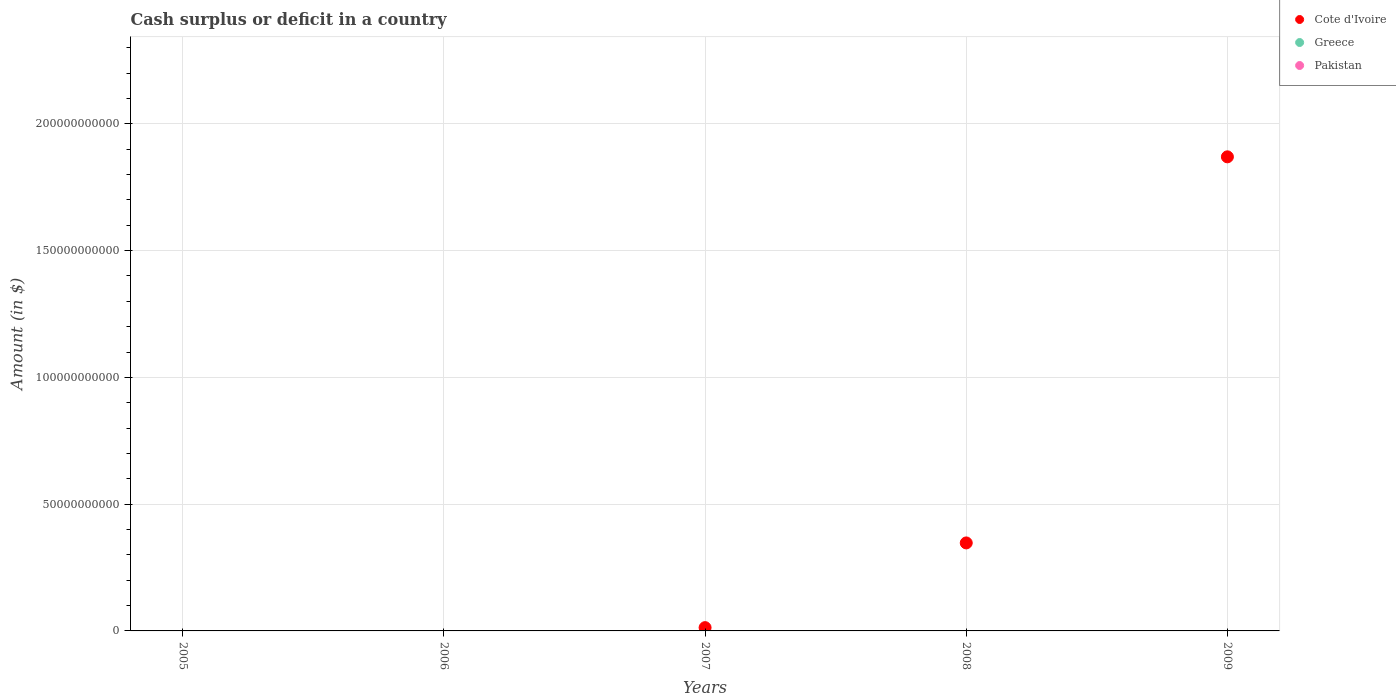How many different coloured dotlines are there?
Keep it short and to the point. 1. What is the amount of cash surplus or deficit in Pakistan in 2007?
Give a very brief answer. 0. Across all years, what is the maximum amount of cash surplus or deficit in Cote d'Ivoire?
Provide a short and direct response. 1.87e+11. In which year was the amount of cash surplus or deficit in Cote d'Ivoire maximum?
Offer a terse response. 2009. What is the total amount of cash surplus or deficit in Cote d'Ivoire in the graph?
Offer a terse response. 2.23e+11. What is the difference between the amount of cash surplus or deficit in Cote d'Ivoire in 2007 and that in 2008?
Your answer should be compact. -3.34e+1. What is the difference between the amount of cash surplus or deficit in Cote d'Ivoire in 2006 and the amount of cash surplus or deficit in Pakistan in 2008?
Provide a short and direct response. 0. What is the ratio of the amount of cash surplus or deficit in Cote d'Ivoire in 2007 to that in 2008?
Offer a very short reply. 0.04. What is the difference between the highest and the second highest amount of cash surplus or deficit in Cote d'Ivoire?
Your answer should be very brief. 1.52e+11. What is the difference between the highest and the lowest amount of cash surplus or deficit in Cote d'Ivoire?
Provide a short and direct response. 1.87e+11. In how many years, is the amount of cash surplus or deficit in Cote d'Ivoire greater than the average amount of cash surplus or deficit in Cote d'Ivoire taken over all years?
Your response must be concise. 1. Is it the case that in every year, the sum of the amount of cash surplus or deficit in Pakistan and amount of cash surplus or deficit in Greece  is greater than the amount of cash surplus or deficit in Cote d'Ivoire?
Keep it short and to the point. No. Does the amount of cash surplus or deficit in Pakistan monotonically increase over the years?
Your response must be concise. No. Are the values on the major ticks of Y-axis written in scientific E-notation?
Give a very brief answer. No. Does the graph contain grids?
Your answer should be very brief. Yes. Where does the legend appear in the graph?
Your response must be concise. Top right. How are the legend labels stacked?
Give a very brief answer. Vertical. What is the title of the graph?
Provide a short and direct response. Cash surplus or deficit in a country. What is the label or title of the Y-axis?
Your response must be concise. Amount (in $). What is the Amount (in $) in Cote d'Ivoire in 2005?
Your response must be concise. 0. What is the Amount (in $) in Greece in 2005?
Offer a very short reply. 0. What is the Amount (in $) in Pakistan in 2005?
Keep it short and to the point. 0. What is the Amount (in $) of Cote d'Ivoire in 2006?
Ensure brevity in your answer.  0. What is the Amount (in $) of Cote d'Ivoire in 2007?
Give a very brief answer. 1.30e+09. What is the Amount (in $) of Greece in 2007?
Offer a very short reply. 0. What is the Amount (in $) of Cote d'Ivoire in 2008?
Your answer should be compact. 3.47e+1. What is the Amount (in $) in Pakistan in 2008?
Your answer should be compact. 0. What is the Amount (in $) of Cote d'Ivoire in 2009?
Offer a terse response. 1.87e+11. What is the Amount (in $) in Greece in 2009?
Your response must be concise. 0. Across all years, what is the maximum Amount (in $) of Cote d'Ivoire?
Your answer should be very brief. 1.87e+11. What is the total Amount (in $) of Cote d'Ivoire in the graph?
Make the answer very short. 2.23e+11. What is the total Amount (in $) in Pakistan in the graph?
Provide a succinct answer. 0. What is the difference between the Amount (in $) in Cote d'Ivoire in 2007 and that in 2008?
Provide a succinct answer. -3.34e+1. What is the difference between the Amount (in $) of Cote d'Ivoire in 2007 and that in 2009?
Your response must be concise. -1.86e+11. What is the difference between the Amount (in $) of Cote d'Ivoire in 2008 and that in 2009?
Provide a short and direct response. -1.52e+11. What is the average Amount (in $) in Cote d'Ivoire per year?
Offer a terse response. 4.46e+1. What is the average Amount (in $) in Greece per year?
Give a very brief answer. 0. What is the average Amount (in $) of Pakistan per year?
Keep it short and to the point. 0. What is the ratio of the Amount (in $) in Cote d'Ivoire in 2007 to that in 2008?
Your answer should be very brief. 0.04. What is the ratio of the Amount (in $) in Cote d'Ivoire in 2007 to that in 2009?
Your answer should be compact. 0.01. What is the ratio of the Amount (in $) of Cote d'Ivoire in 2008 to that in 2009?
Ensure brevity in your answer.  0.19. What is the difference between the highest and the second highest Amount (in $) in Cote d'Ivoire?
Offer a very short reply. 1.52e+11. What is the difference between the highest and the lowest Amount (in $) in Cote d'Ivoire?
Your answer should be very brief. 1.87e+11. 